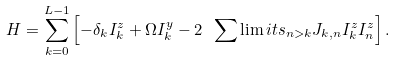Convert formula to latex. <formula><loc_0><loc_0><loc_500><loc_500>H = \sum _ { k = 0 } ^ { L - 1 } \left [ - \delta _ { k } I ^ { z } _ { k } + \Omega I ^ { y } _ { k } - 2 \ \sum \lim i t s _ { n > k } J _ { k , n } I ^ { z } _ { k } I ^ { z } _ { n } \right ] .</formula> 